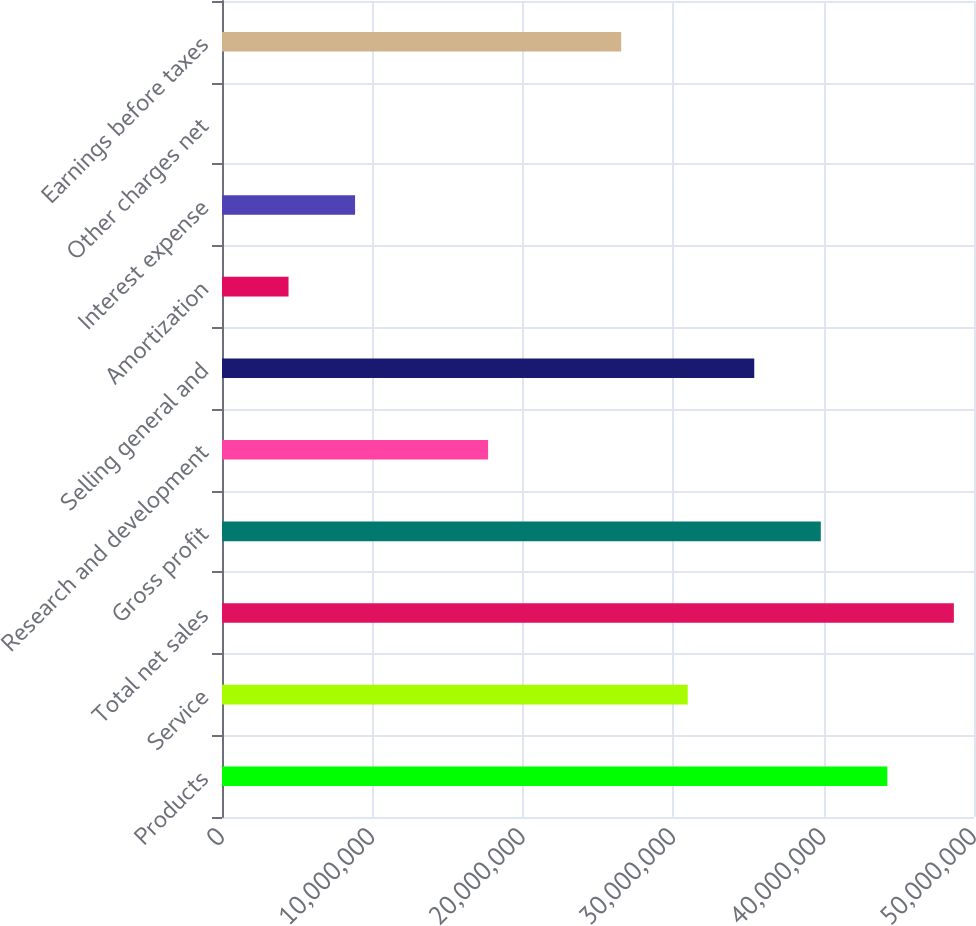Convert chart to OTSL. <chart><loc_0><loc_0><loc_500><loc_500><bar_chart><fcel>Products<fcel>Service<fcel>Total net sales<fcel>Gross profit<fcel>Research and development<fcel>Selling general and<fcel>Amortization<fcel>Interest expense<fcel>Other charges net<fcel>Earnings before taxes<nl><fcel>4.42372e+07<fcel>3.09661e+07<fcel>4.86609e+07<fcel>3.98135e+07<fcel>1.76949e+07<fcel>3.53898e+07<fcel>4.42376e+06<fcel>8.84748e+06<fcel>42<fcel>2.65423e+07<nl></chart> 